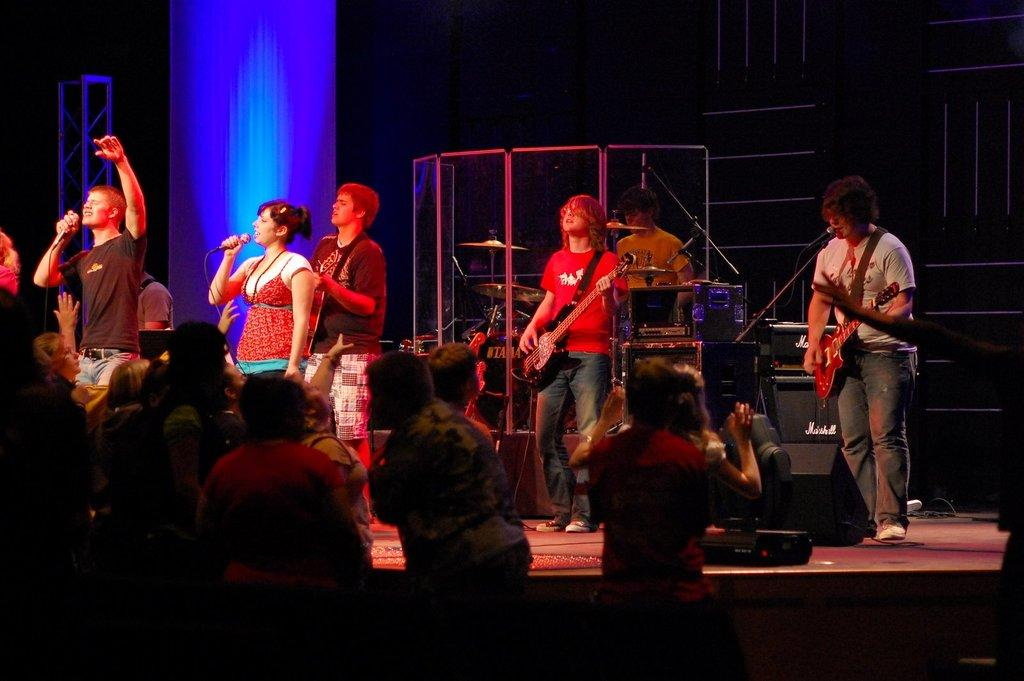What are the people on the stage doing? The people on the stage are standing and performing. What objects are some people holding on the stage? Some people on the stage are holding microphones and guitars. Are there any people not on the stage? Yes, there are people not on the stage. What is the chance of a hand thrilling the audience in the image? There is no mention of a hand thrilling the audience in the image, nor is there any indication of a chance involved. 